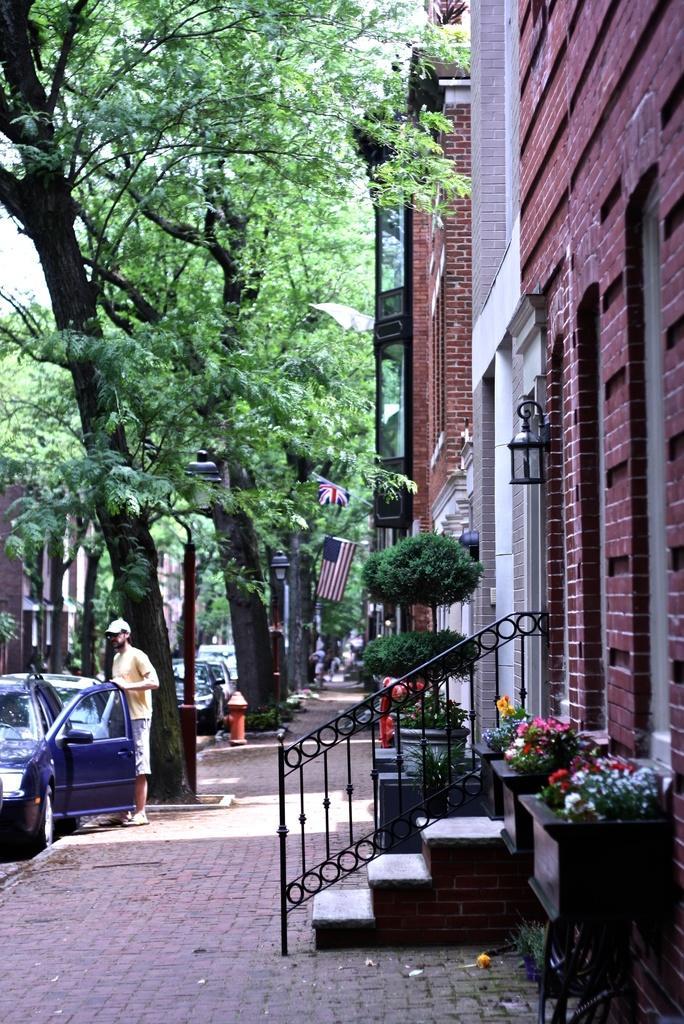How would you summarize this image in a sentence or two? This image consists of building in brown color made up of bricks. In the front, there are steps along with the railing. To the left, there is a car in blue color beside which a man is standing. In the background, there are trees. At the bottom, there is a pavement. 